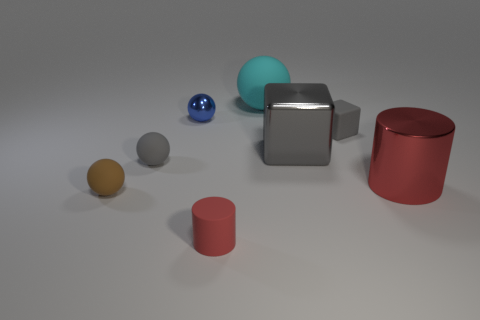Subtract all large balls. How many balls are left? 3 Add 2 gray blocks. How many objects exist? 10 Subtract all gray spheres. How many spheres are left? 3 Subtract all gray cylinders. How many green cubes are left? 0 Subtract all cyan metallic balls. Subtract all tiny cylinders. How many objects are left? 7 Add 4 tiny blue metallic balls. How many tiny blue metallic balls are left? 5 Add 4 metallic objects. How many metallic objects exist? 7 Subtract 0 brown blocks. How many objects are left? 8 Subtract all blocks. How many objects are left? 6 Subtract 1 blocks. How many blocks are left? 1 